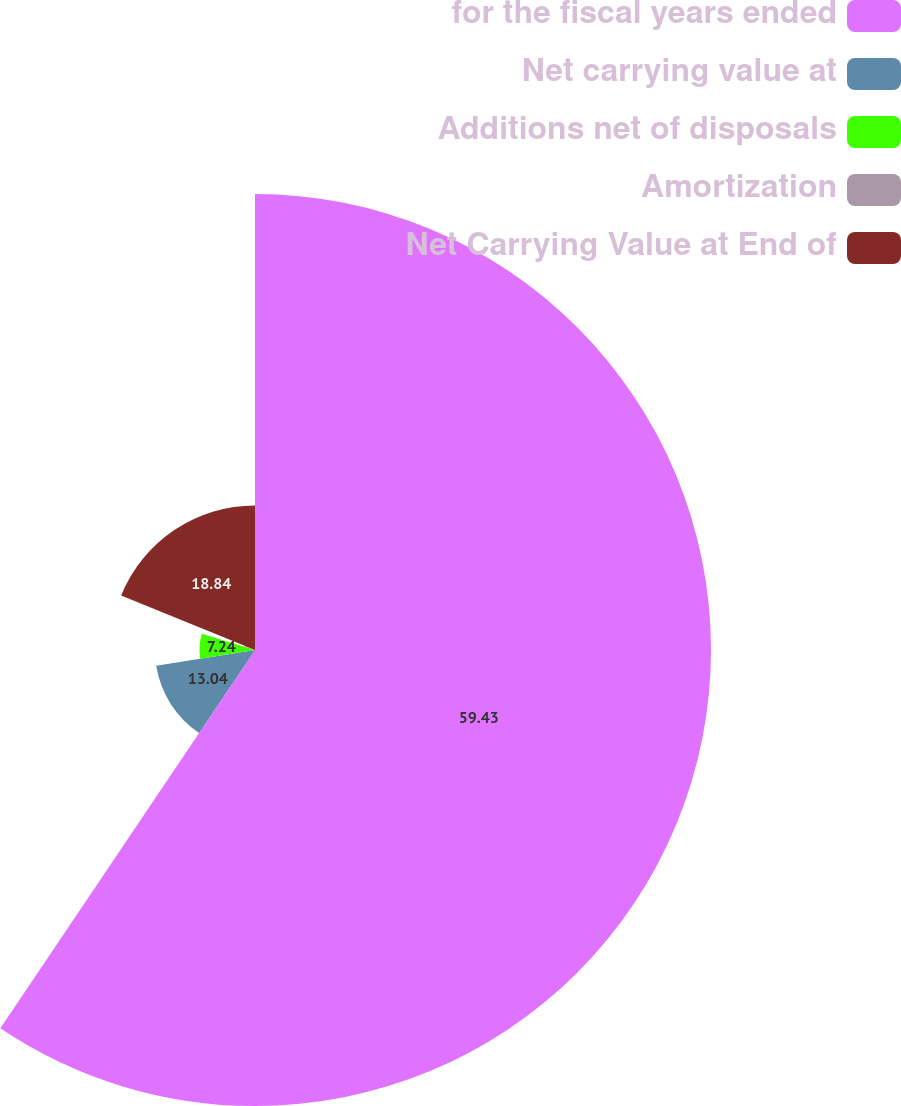<chart> <loc_0><loc_0><loc_500><loc_500><pie_chart><fcel>for the fiscal years ended<fcel>Net carrying value at<fcel>Additions net of disposals<fcel>Amortization<fcel>Net Carrying Value at End of<nl><fcel>59.43%<fcel>13.04%<fcel>7.24%<fcel>1.45%<fcel>18.84%<nl></chart> 